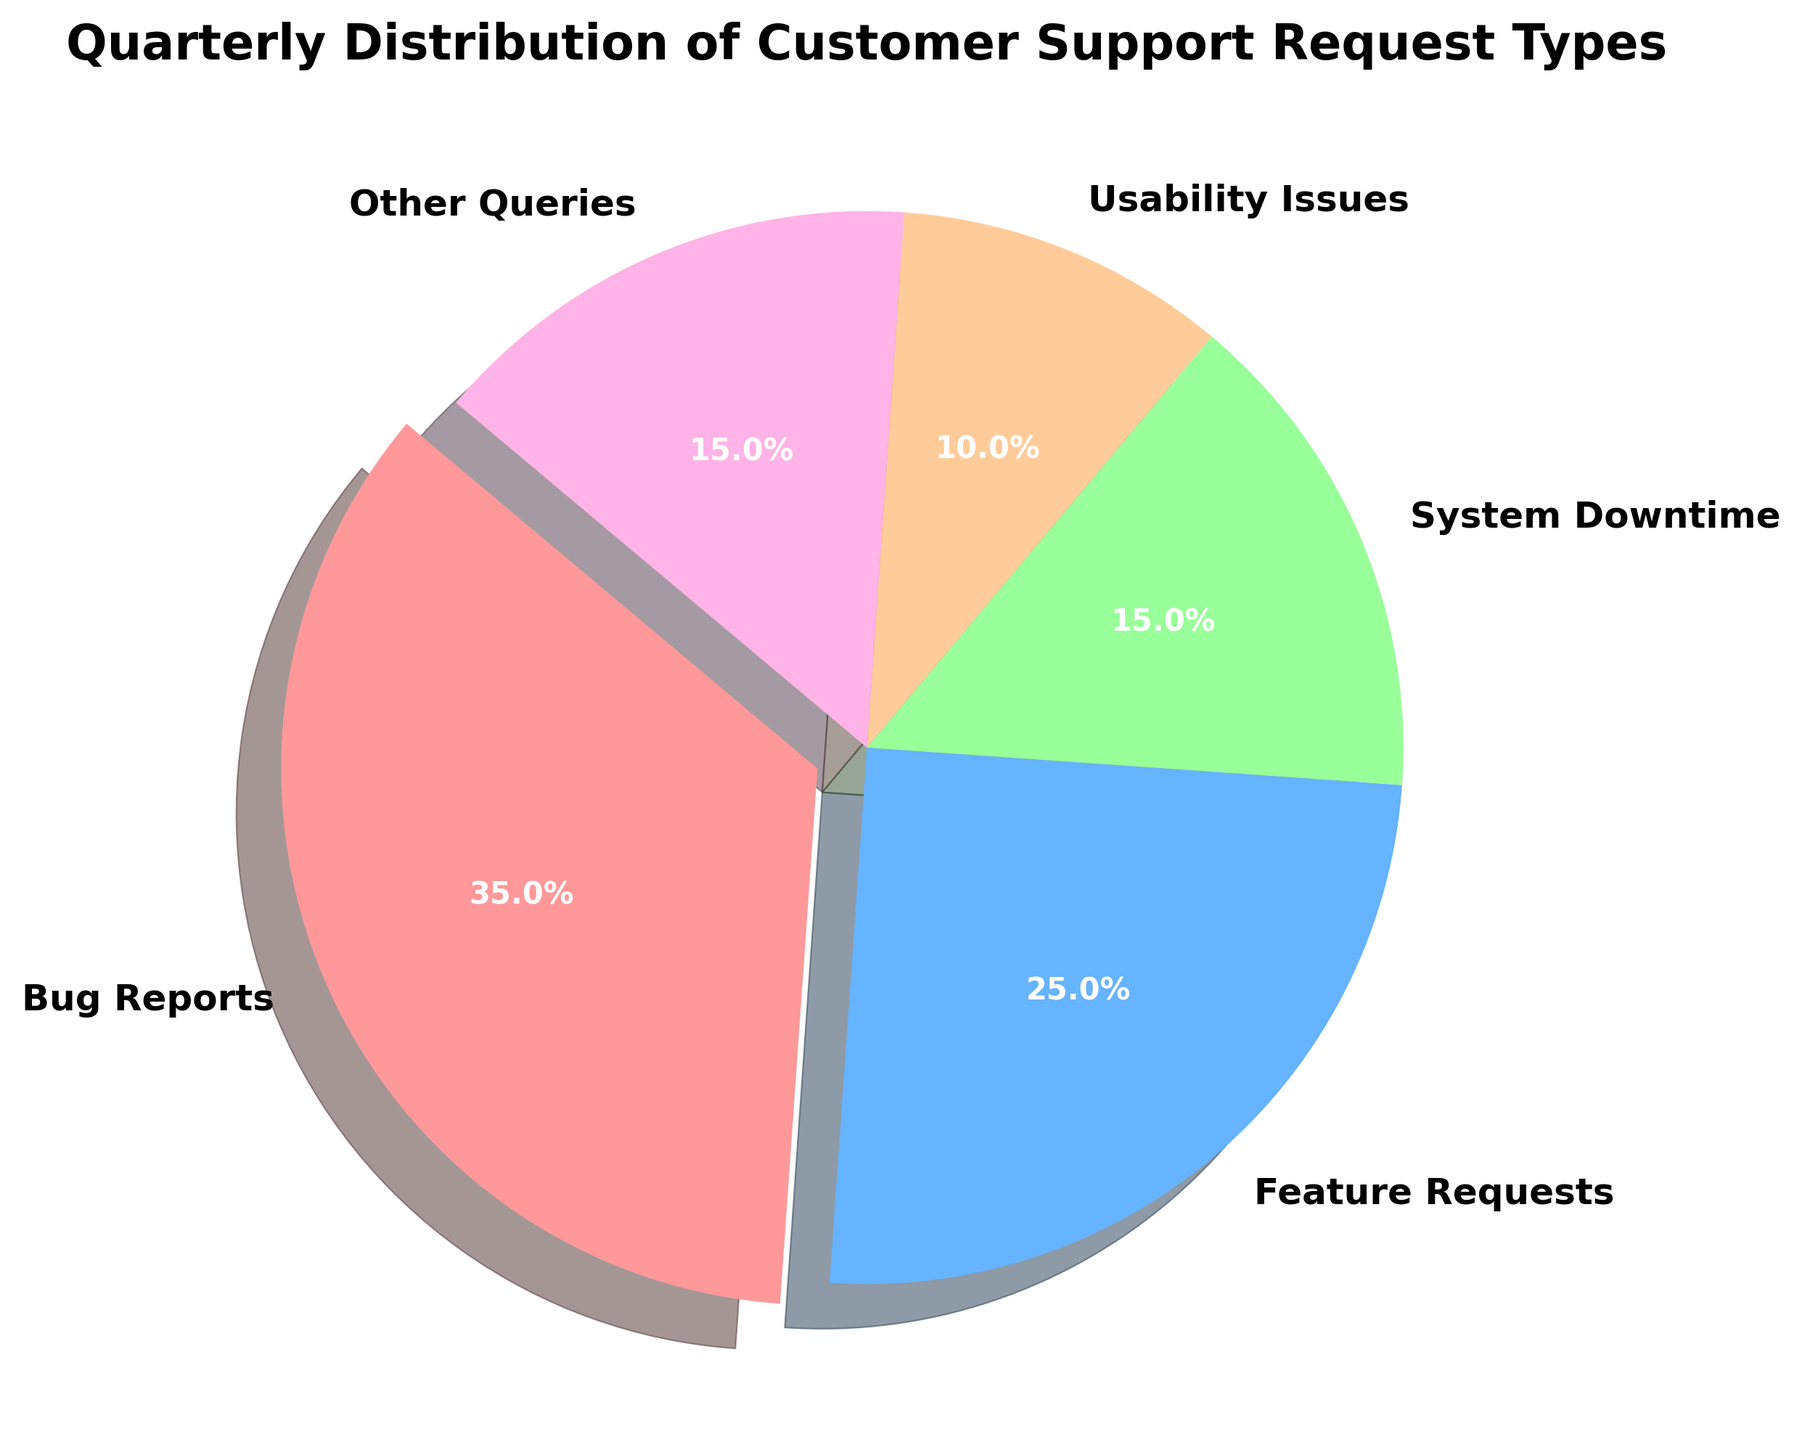What percentage of customer support requests are related to Bug Reports? According to the pie chart, Bug Reports constitute 35% of the requests. They are visually represented as the largest segment of the chart.
Answer: 35% Which type of customer support request is the second most frequent? By examining the size of each segment in the pie chart, we see that Feature Requests, at 25%, is the second largest segment after Bug Reports.
Answer: Feature Requests What is the combined percentage of System Downtime and Other Queries? The percentages for System Downtime and Other Queries are 15% each. Adding these values gives 15% + 15% = 30%.
Answer: 30% Is the percentage of Usability Issues greater than the percentage of System Downtime? The pie chart shows Usability Issues at 10% and System Downtime at 15%. Since 10% is less than 15%, Usability Issues account for a smaller percentage than System Downtime.
Answer: No Which type of support request is represented by the pink color? The pink segment in the pie chart corresponds to Bug Reports, which constitute 35% of the requests.
Answer: Bug Reports Are Feature Requests and Usability Issues combined equal to the percentage of Bug Reports? Feature Requests are 25% and Usability Issues are 10%. Adding these gives 25% + 10% = 35%, which is indeed the same as the percentage of Bug Reports.
Answer: Yes What is the difference in the percentage between Bug Reports and Usability Issues? Bug Reports are 35% and Usability Issues are 10%. The difference is 35% - 10% = 25%.
Answer: 25% How many different types of customer support requests are depicted in the pie chart? The pie chart includes five different types: Bug Reports, Feature Requests, System Downtime, Usability Issues, and Other Queries.
Answer: 5 If the total number of requests is 1000, how many requests are Feature Requests? Feature Requests represent 25% of the total. Therefore, 25% of 1000 is calculated as 1000 * 0.25 = 250.
Answer: 250 Which segment appears visually larger: System Downtime or Usability Issues? By visual inspection, System Downtime, at 15%, has a larger segment compared to Usability Issues, which is 10%.
Answer: System Downtime 